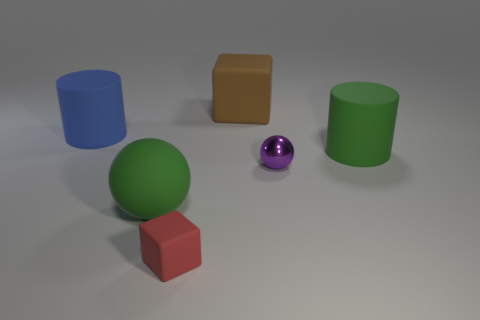What is the material of the big green thing to the right of the big green sphere?
Your answer should be compact. Rubber. What is the size of the red thing that is made of the same material as the blue cylinder?
Your answer should be compact. Small. Are there any tiny blocks left of the big blue rubber cylinder?
Your response must be concise. No. There is a red thing that is the same shape as the large brown thing; what is its size?
Provide a short and direct response. Small. There is a big matte ball; is its color the same as the cylinder that is right of the red thing?
Provide a short and direct response. Yes. Do the metal sphere and the small matte object have the same color?
Your answer should be very brief. No. Are there fewer tiny purple metallic objects than large cyan rubber balls?
Make the answer very short. No. How many other things are there of the same color as the large rubber block?
Give a very brief answer. 0. How many big brown blocks are there?
Provide a succinct answer. 1. Are there fewer rubber cylinders on the right side of the brown block than small brown cubes?
Ensure brevity in your answer.  No. 